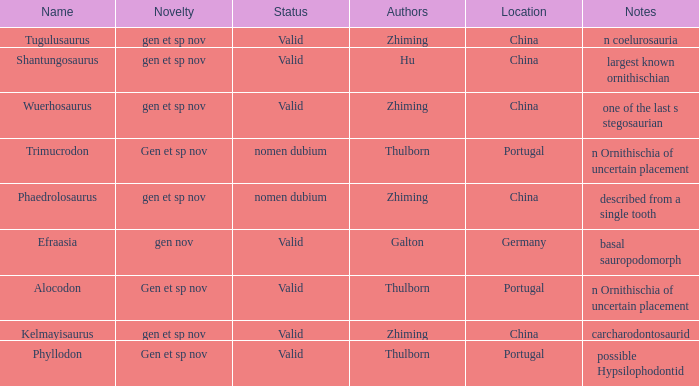What is the Name of the dinosaur that was discovered in the Location, China, and whose Notes are, "described from a single tooth"? Phaedrolosaurus. 